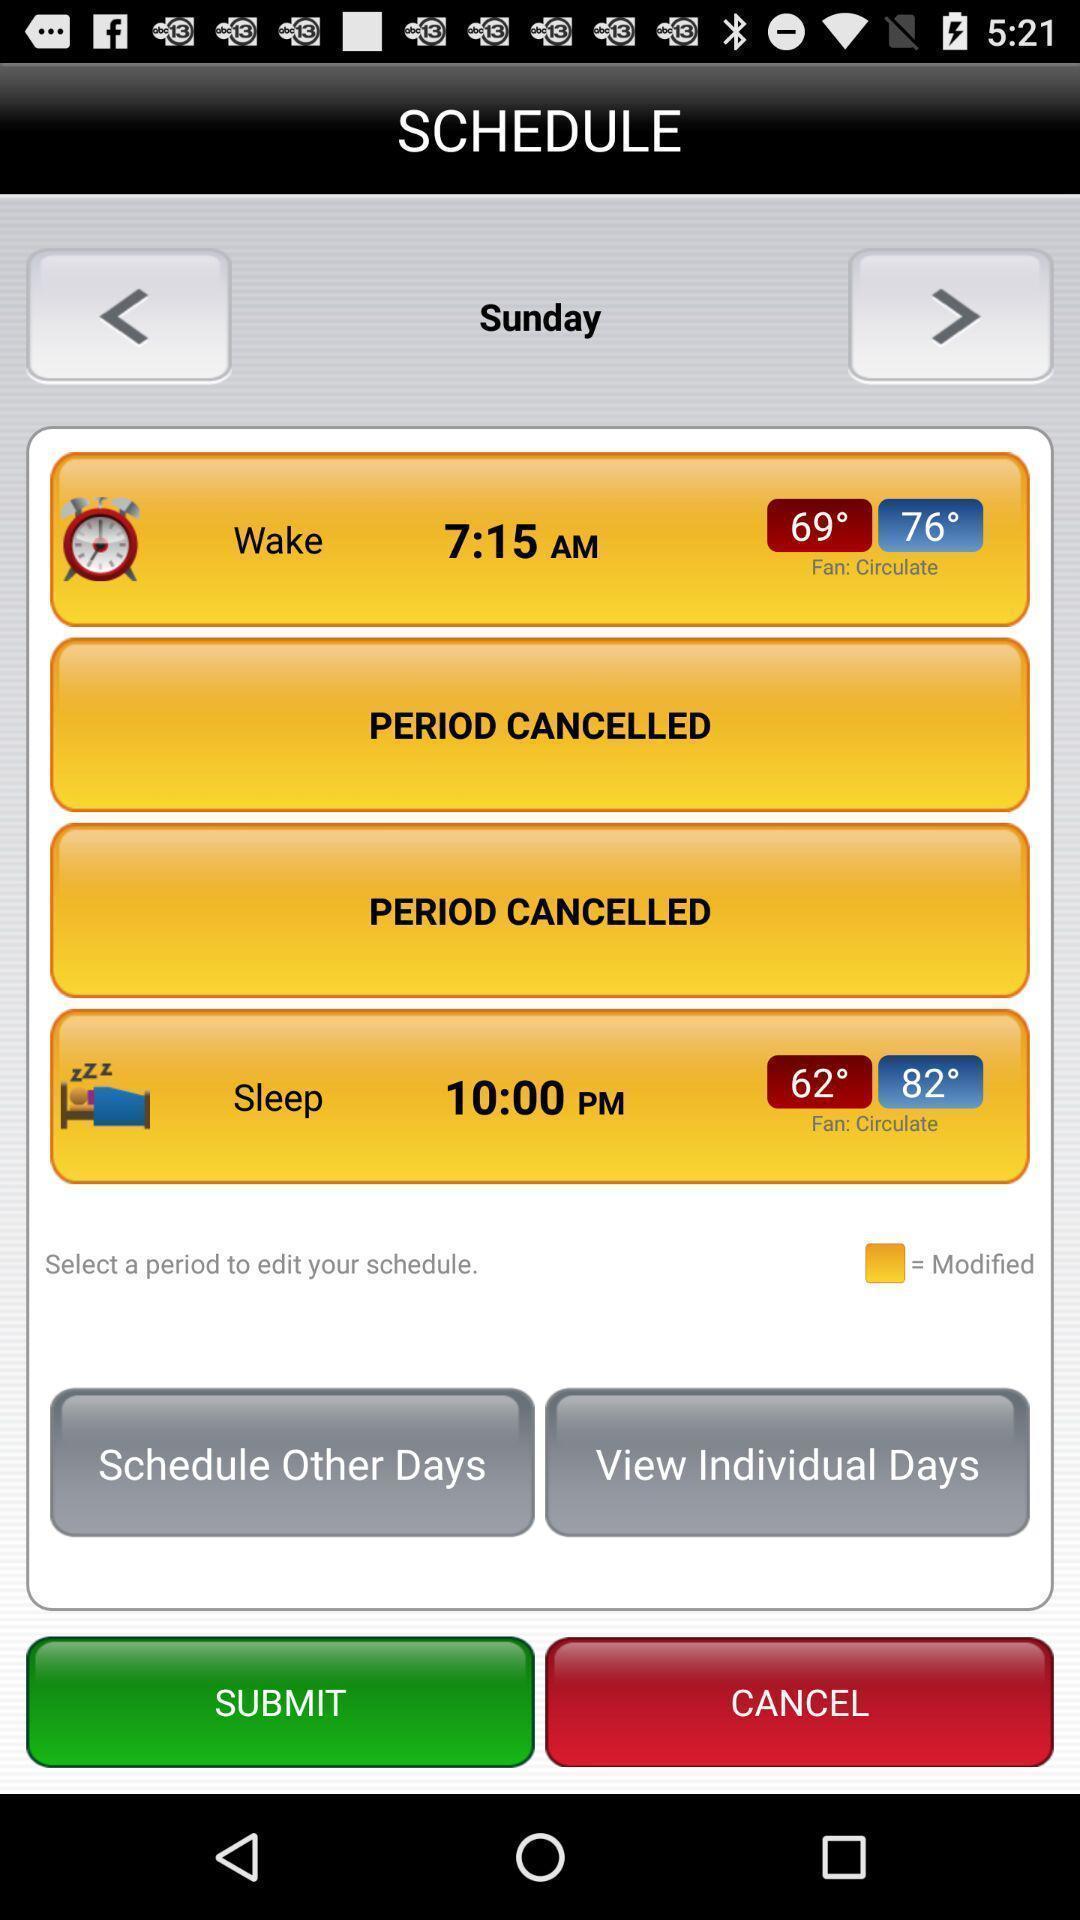Give me a narrative description of this picture. Screen displaying schedule for sleep and wake times. 